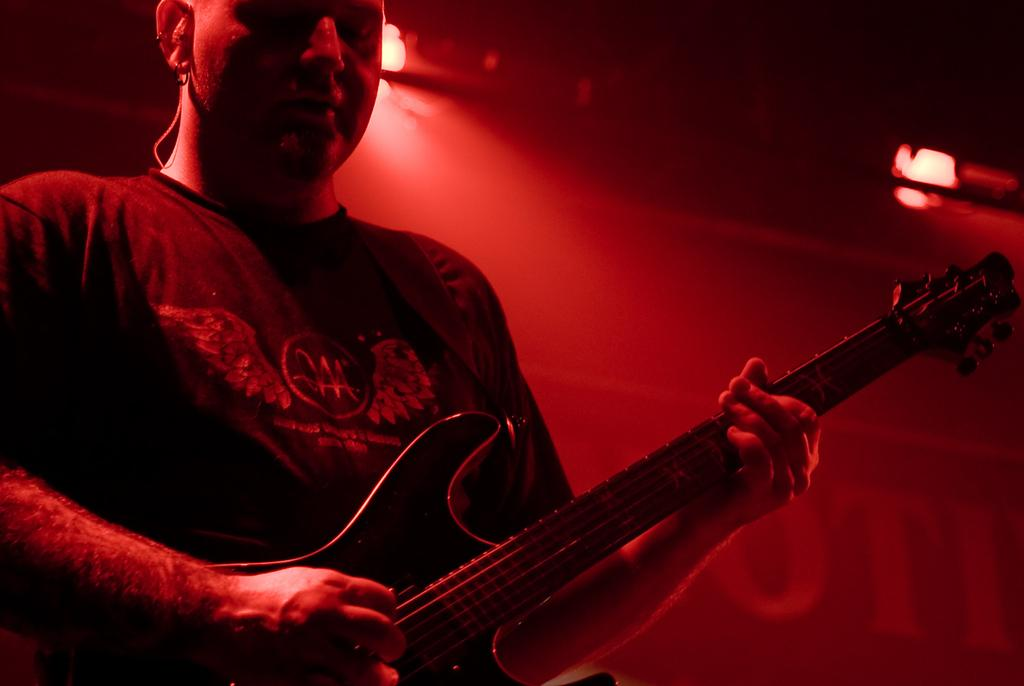What is the man in the picture doing? The man is playing the guitar. What object is the man holding in the picture? The man is holding a guitar. Can you describe the background of the image? There is a red colored light in the background of the image. How many trains can be seen in the image? There are no trains present in the image. What type of roof is visible in the image? There is no roof visible in the image. 